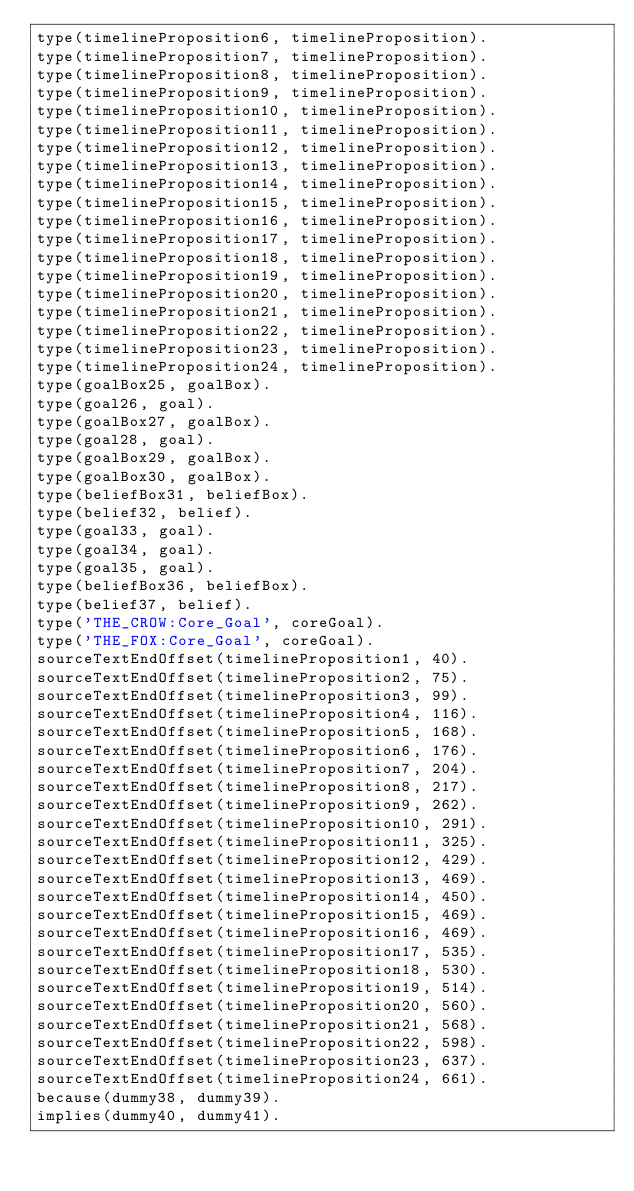<code> <loc_0><loc_0><loc_500><loc_500><_Prolog_>type(timelineProposition6, timelineProposition).
type(timelineProposition7, timelineProposition).
type(timelineProposition8, timelineProposition).
type(timelineProposition9, timelineProposition).
type(timelineProposition10, timelineProposition).
type(timelineProposition11, timelineProposition).
type(timelineProposition12, timelineProposition).
type(timelineProposition13, timelineProposition).
type(timelineProposition14, timelineProposition).
type(timelineProposition15, timelineProposition).
type(timelineProposition16, timelineProposition).
type(timelineProposition17, timelineProposition).
type(timelineProposition18, timelineProposition).
type(timelineProposition19, timelineProposition).
type(timelineProposition20, timelineProposition).
type(timelineProposition21, timelineProposition).
type(timelineProposition22, timelineProposition).
type(timelineProposition23, timelineProposition).
type(timelineProposition24, timelineProposition).
type(goalBox25, goalBox).
type(goal26, goal).
type(goalBox27, goalBox).
type(goal28, goal).
type(goalBox29, goalBox).
type(goalBox30, goalBox).
type(beliefBox31, beliefBox).
type(belief32, belief).
type(goal33, goal).
type(goal34, goal).
type(goal35, goal).
type(beliefBox36, beliefBox).
type(belief37, belief).
type('THE_CROW:Core_Goal', coreGoal).
type('THE_FOX:Core_Goal', coreGoal).
sourceTextEndOffset(timelineProposition1, 40).
sourceTextEndOffset(timelineProposition2, 75).
sourceTextEndOffset(timelineProposition3, 99).
sourceTextEndOffset(timelineProposition4, 116).
sourceTextEndOffset(timelineProposition5, 168).
sourceTextEndOffset(timelineProposition6, 176).
sourceTextEndOffset(timelineProposition7, 204).
sourceTextEndOffset(timelineProposition8, 217).
sourceTextEndOffset(timelineProposition9, 262).
sourceTextEndOffset(timelineProposition10, 291).
sourceTextEndOffset(timelineProposition11, 325).
sourceTextEndOffset(timelineProposition12, 429).
sourceTextEndOffset(timelineProposition13, 469).
sourceTextEndOffset(timelineProposition14, 450).
sourceTextEndOffset(timelineProposition15, 469).
sourceTextEndOffset(timelineProposition16, 469).
sourceTextEndOffset(timelineProposition17, 535).
sourceTextEndOffset(timelineProposition18, 530).
sourceTextEndOffset(timelineProposition19, 514).
sourceTextEndOffset(timelineProposition20, 560).
sourceTextEndOffset(timelineProposition21, 568).
sourceTextEndOffset(timelineProposition22, 598).
sourceTextEndOffset(timelineProposition23, 637).
sourceTextEndOffset(timelineProposition24, 661).
because(dummy38, dummy39).
implies(dummy40, dummy41).</code> 